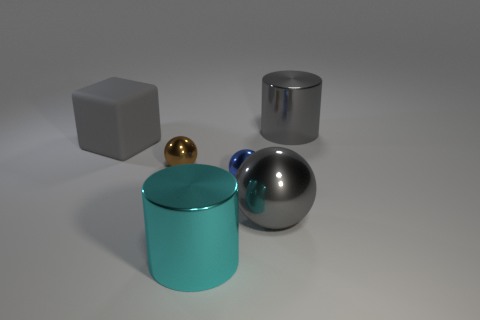Considering the objects in this image, what can you infer about the environment they are in? The objects are situated on a neutral ground with a subtle reflection, suggesting an indoor setting with a clean, minimalist aesthetic, possibly a studio environment where the focus is on the objects themselves rather than their surroundings. 